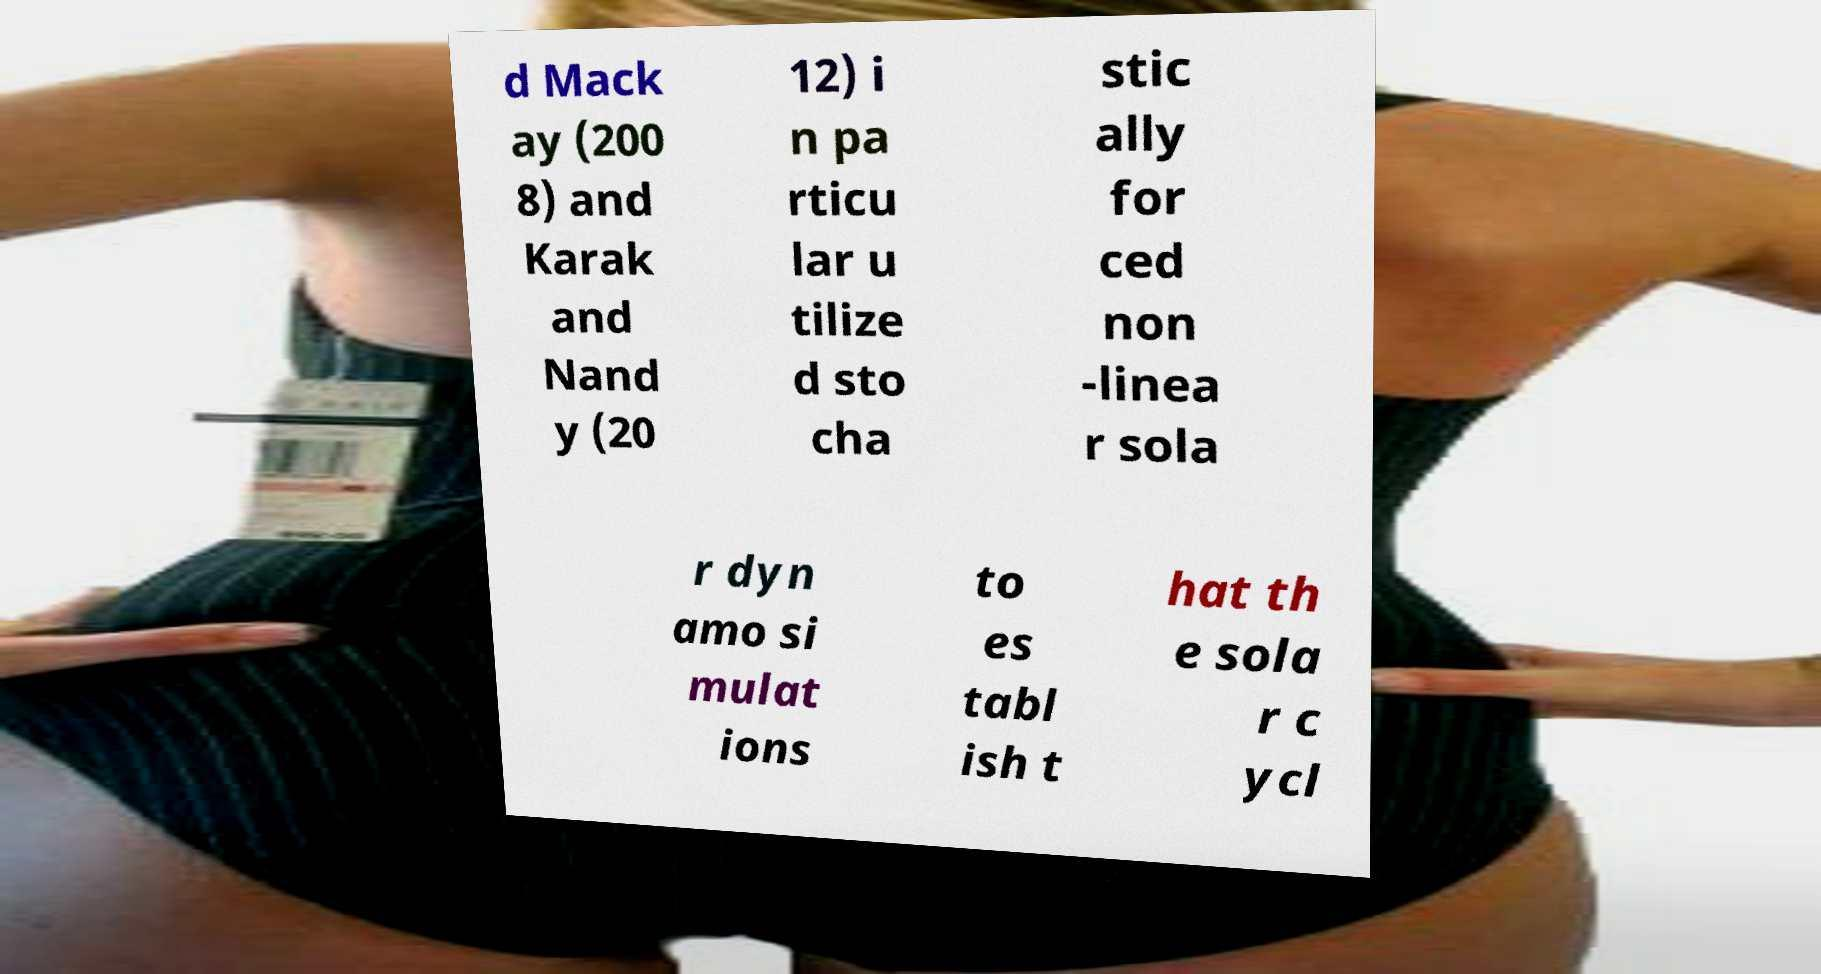There's text embedded in this image that I need extracted. Can you transcribe it verbatim? d Mack ay (200 8) and Karak and Nand y (20 12) i n pa rticu lar u tilize d sto cha stic ally for ced non -linea r sola r dyn amo si mulat ions to es tabl ish t hat th e sola r c ycl 